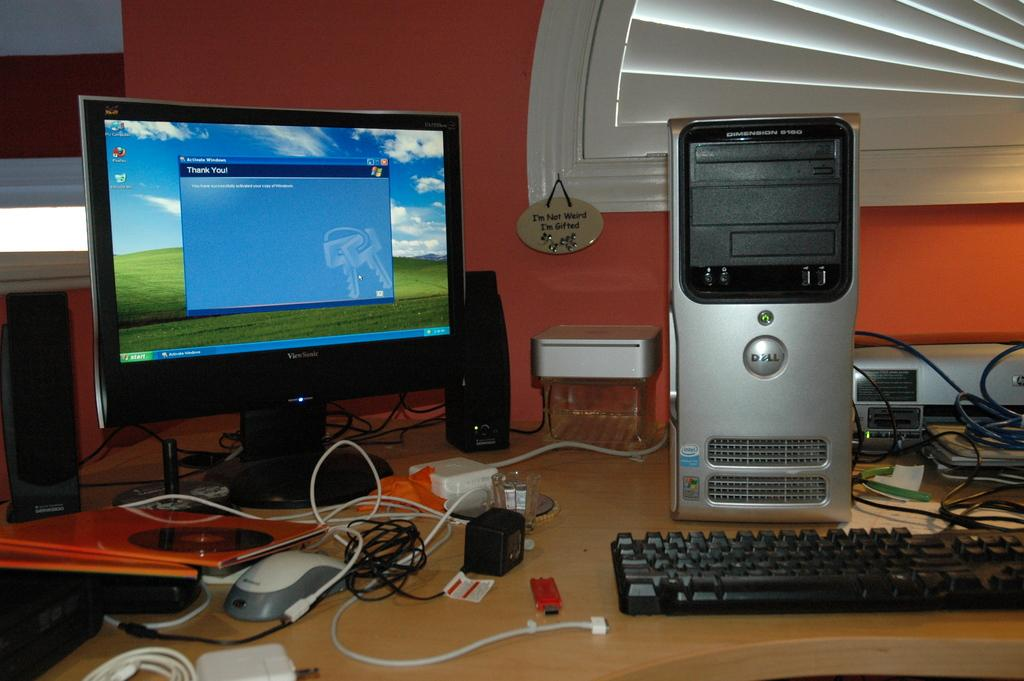<image>
Present a compact description of the photo's key features. Desktop computer that has a screen saying Thank You. 